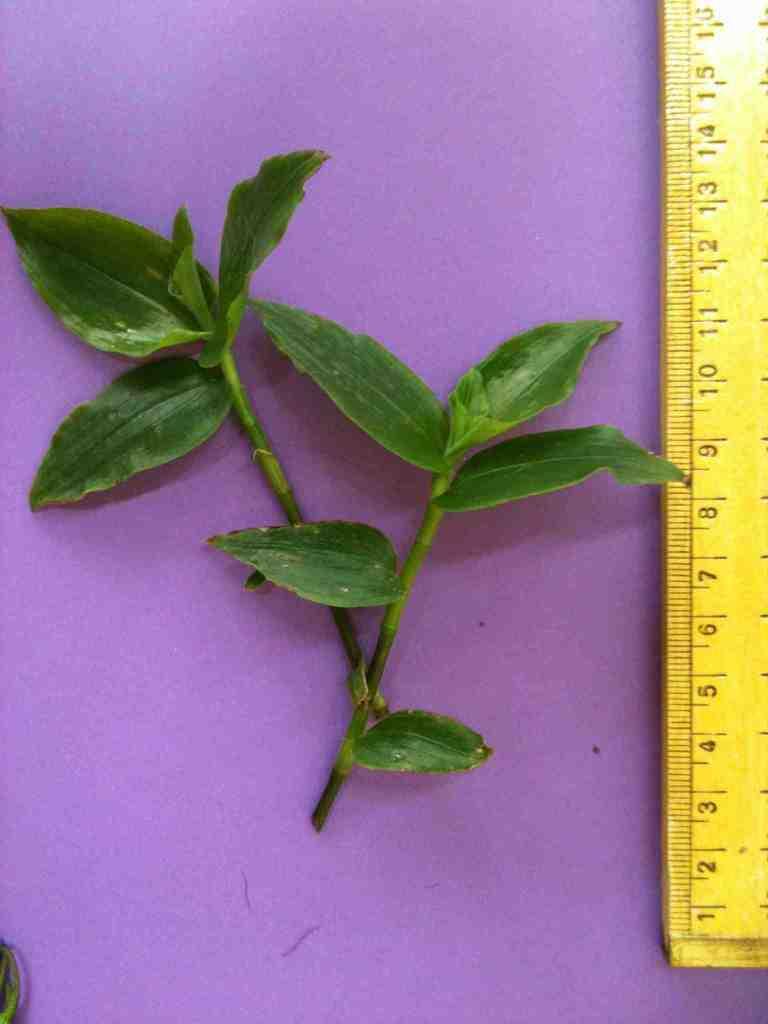What is the highest number shown on the ruler?
Offer a terse response. 16. Approximately how long is this clipping?
Ensure brevity in your answer.  13 inches. 